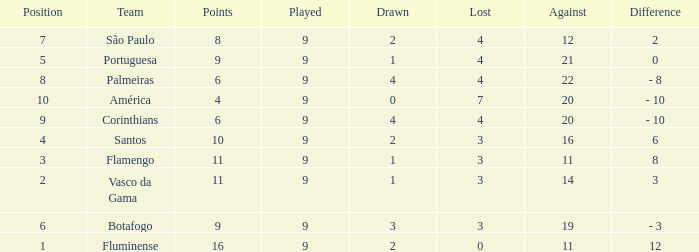What is the highest against that possesses a 12-point difference? 11.0. 